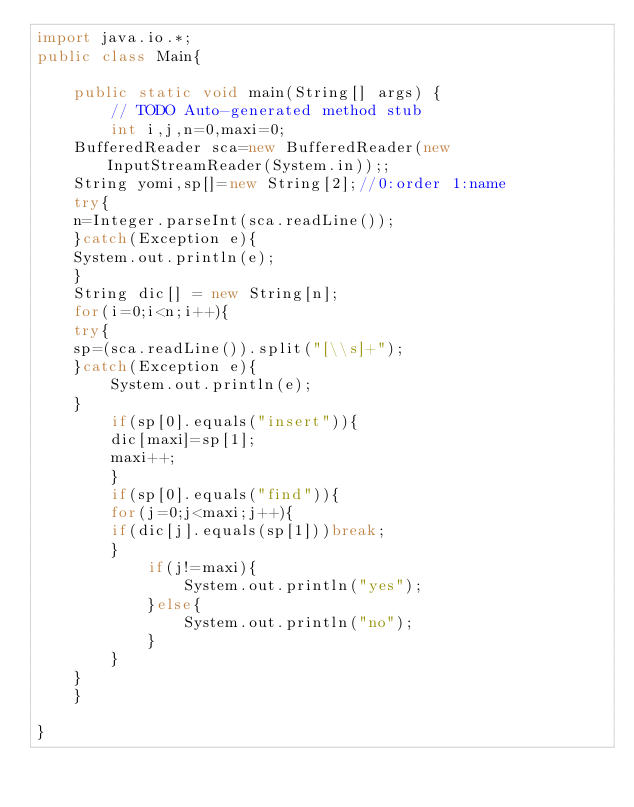<code> <loc_0><loc_0><loc_500><loc_500><_Java_>import java.io.*;
public class Main{

	public static void main(String[] args) {
		// TODO Auto-generated method stub
	    int i,j,n=0,maxi=0;
    BufferedReader sca=new BufferedReader(new InputStreamReader(System.in));;
    String yomi,sp[]=new String[2];//0:order 1:name
    try{
    n=Integer.parseInt(sca.readLine());
    }catch(Exception e){
	System.out.println(e);
    }
    String dic[] = new String[n];
    for(i=0;i<n;i++){
	try{
	sp=(sca.readLine()).split("[\\s]+");
	}catch(Exception e){
	    System.out.println(e);
	}
    	if(sp[0].equals("insert")){
	    dic[maxi]=sp[1];
	    maxi++;
    	}
    	if(sp[0].equals("find")){
	    for(j=0;j<maxi;j++){
		if(dic[j].equals(sp[1]))break;
	    }
    		if(j!=maxi){
    			System.out.println("yes");
    		}else{
    			System.out.println("no");
    		}
    	}
    }
	}

}
</code> 